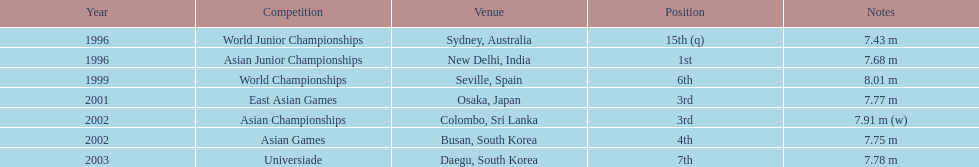What is the discrepancy in the occurrences of reaching first and third positions? 1. 